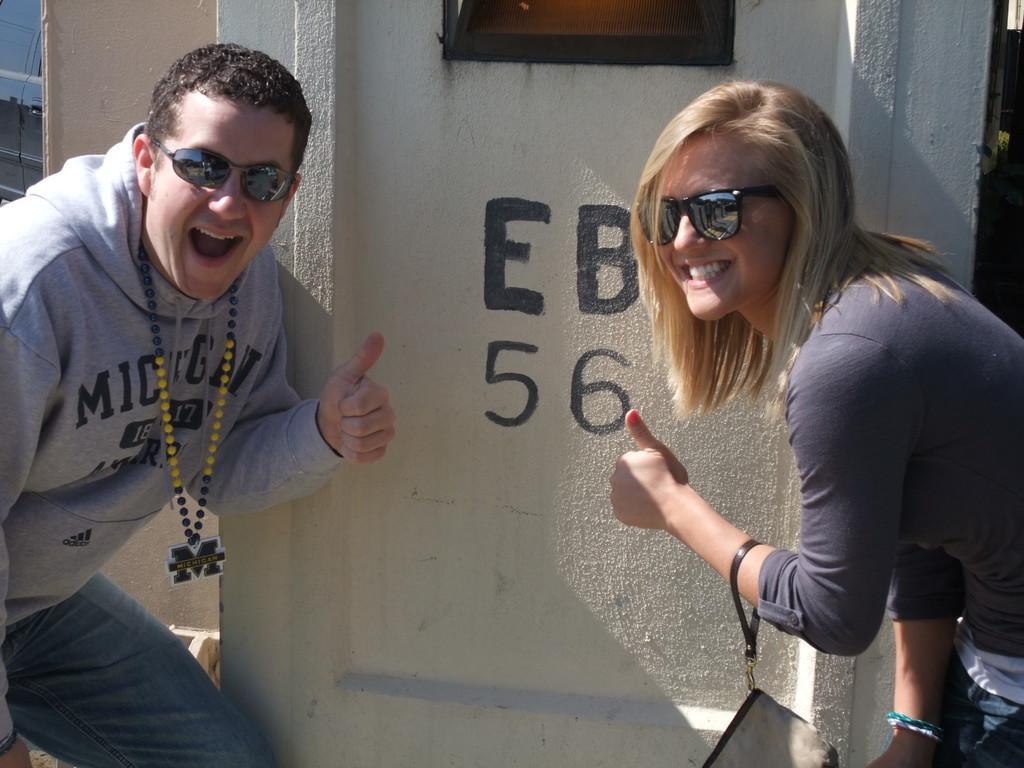Describe this image in one or two sentences. In this picture, there is a man towards the left and a woman towards the right. Both of them are wearing grey clothes and goggles. Woman is carrying a bag. In between them, there is a wall with some text and a window. 